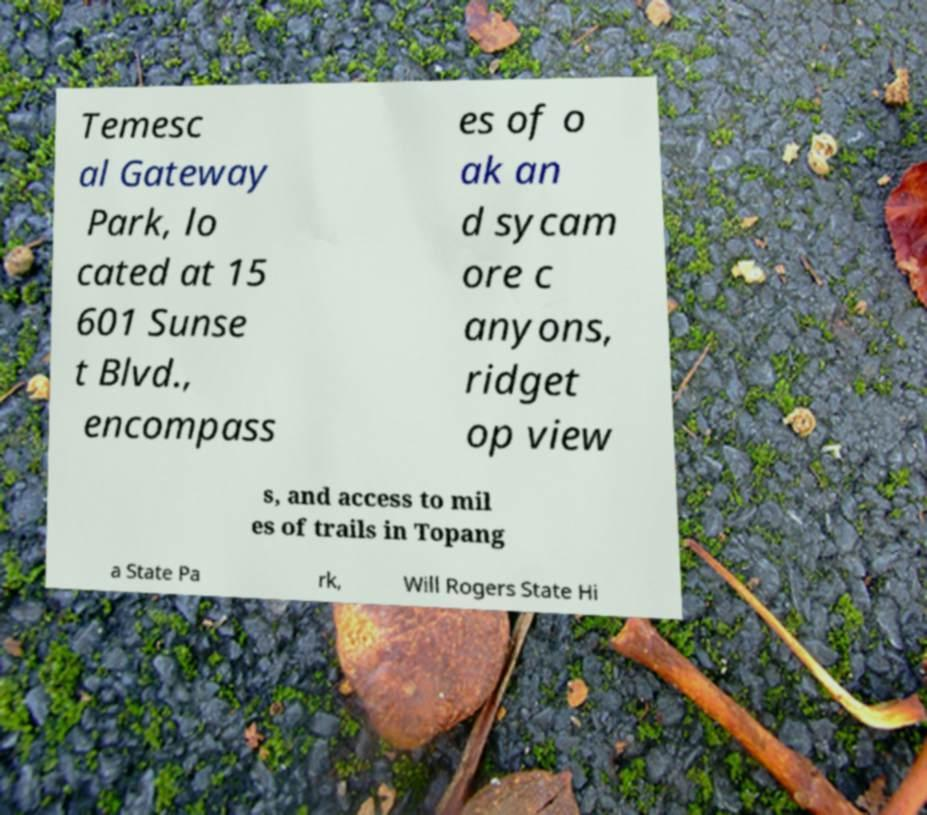Could you assist in decoding the text presented in this image and type it out clearly? Temesc al Gateway Park, lo cated at 15 601 Sunse t Blvd., encompass es of o ak an d sycam ore c anyons, ridget op view s, and access to mil es of trails in Topang a State Pa rk, Will Rogers State Hi 